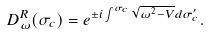Convert formula to latex. <formula><loc_0><loc_0><loc_500><loc_500>D _ { \omega } ^ { R } ( \sigma _ { c } ) = e ^ { \pm i \int ^ { \sigma _ { c } } \sqrt { \omega ^ { 2 } - V } d \sigma ^ { \prime } _ { c } } .</formula> 